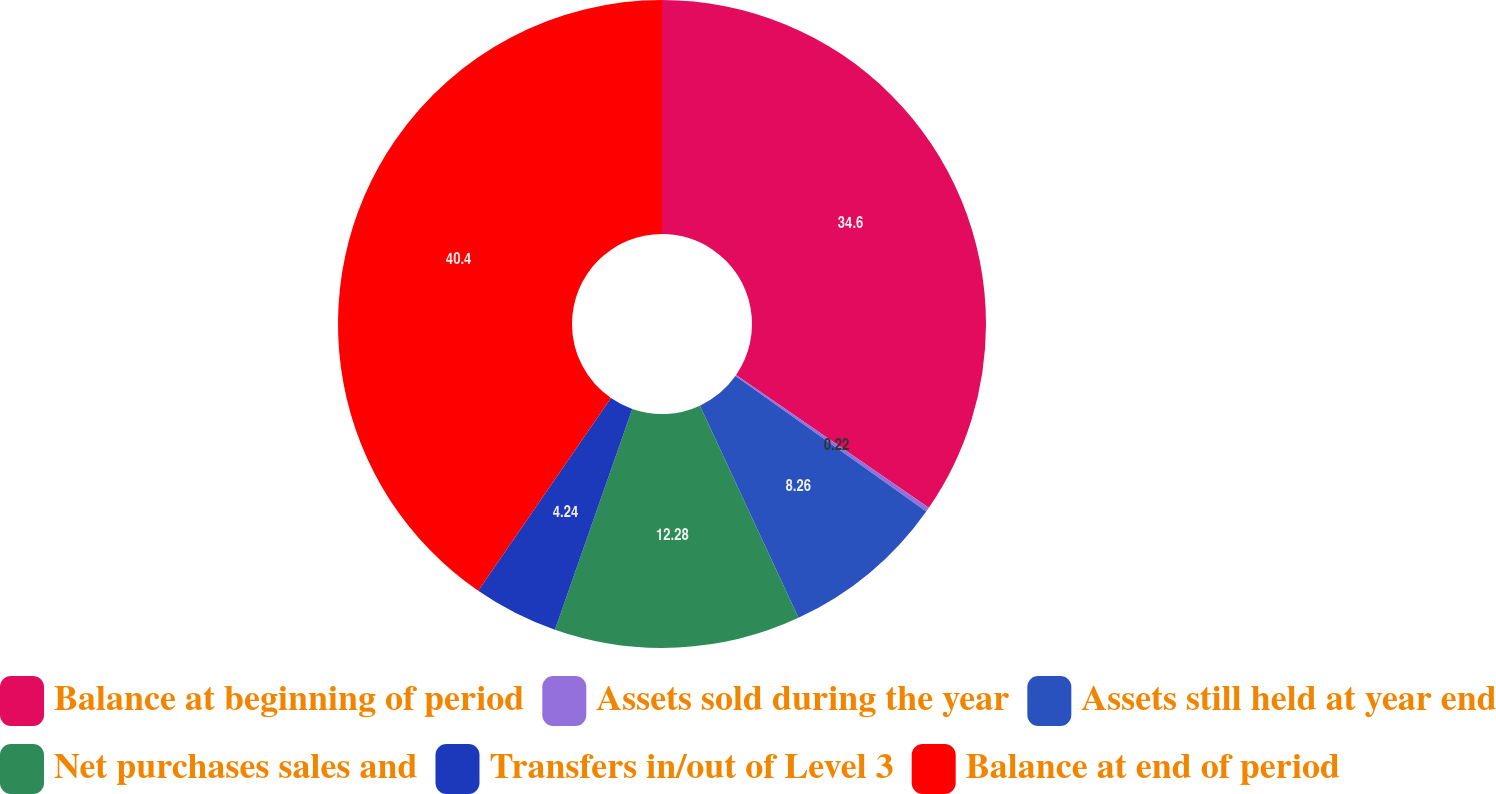<chart> <loc_0><loc_0><loc_500><loc_500><pie_chart><fcel>Balance at beginning of period<fcel>Assets sold during the year<fcel>Assets still held at year end<fcel>Net purchases sales and<fcel>Transfers in/out of Level 3<fcel>Balance at end of period<nl><fcel>34.6%<fcel>0.22%<fcel>8.26%<fcel>12.28%<fcel>4.24%<fcel>40.4%<nl></chart> 